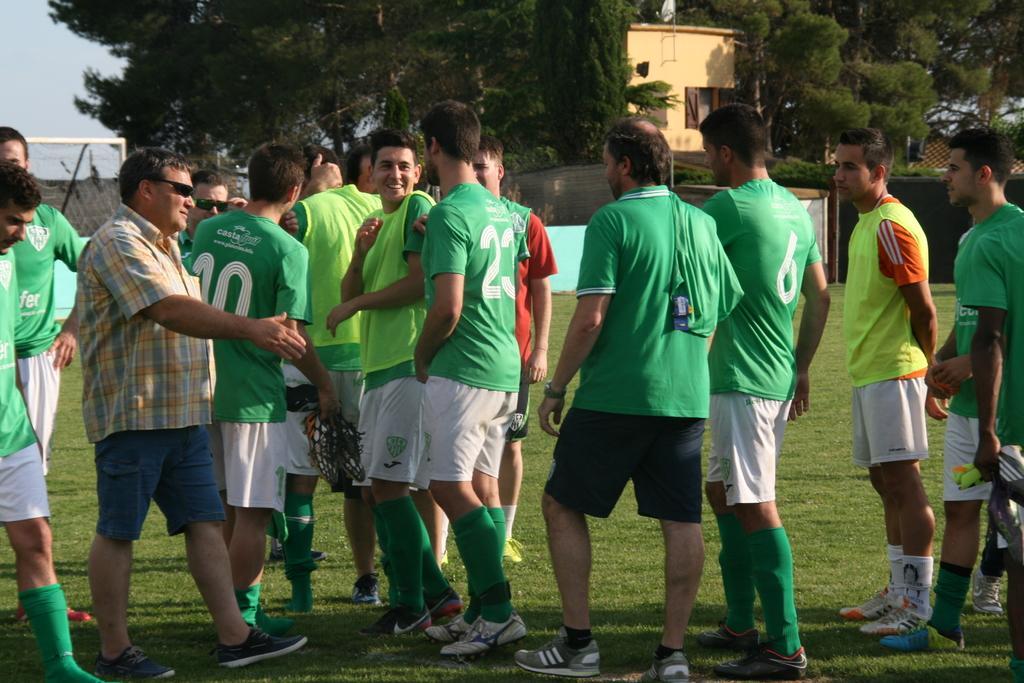Please provide a concise description of this image. In this picture we can see a few people standing on the ground. Some grass is visible on the ground. There is a net on the left side. We can see a few trees and a building in the background. 